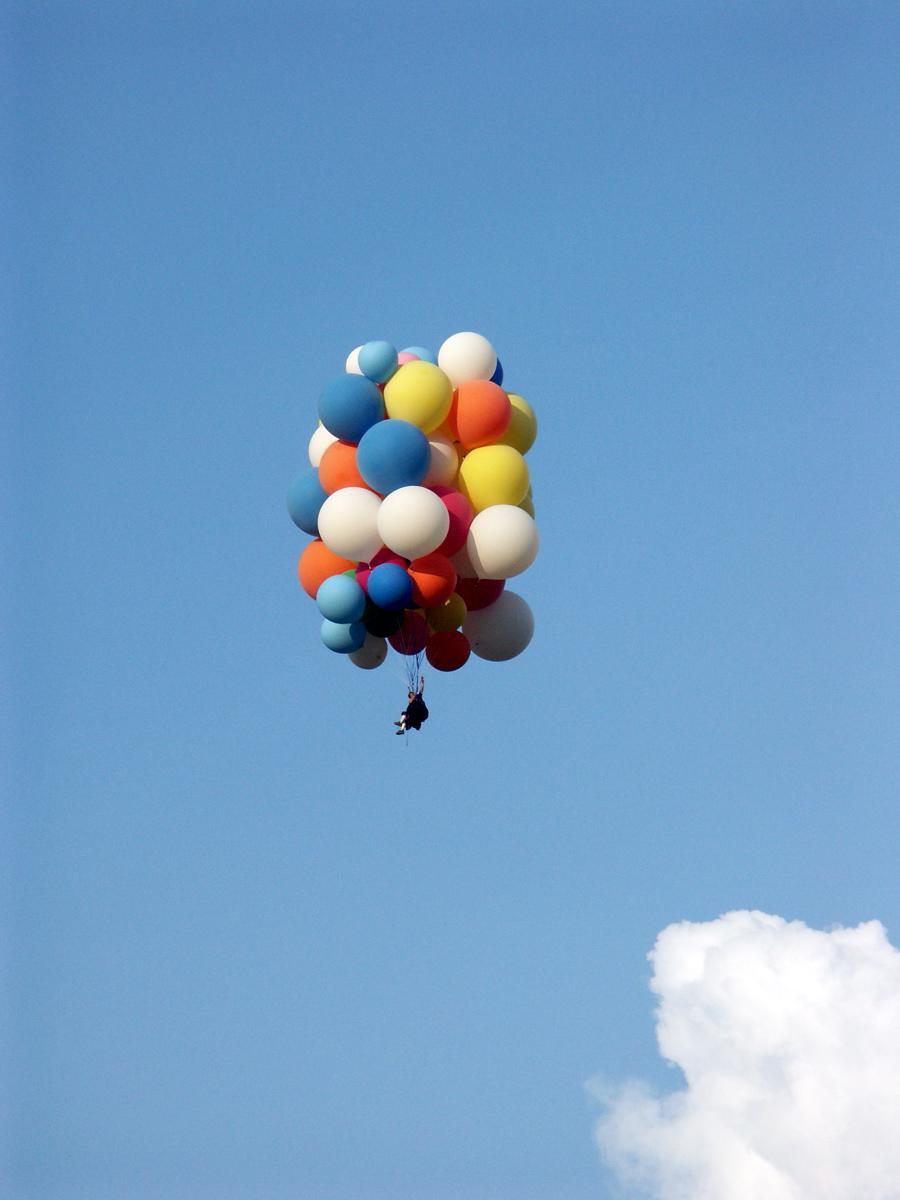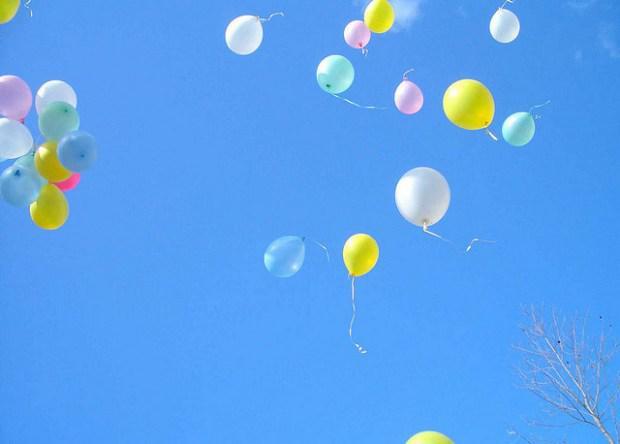The first image is the image on the left, the second image is the image on the right. Assess this claim about the two images: "There are balloons tied together.". Correct or not? Answer yes or no. Yes. The first image is the image on the left, the second image is the image on the right. Given the left and right images, does the statement "There are three hot air balloons." hold true? Answer yes or no. No. 